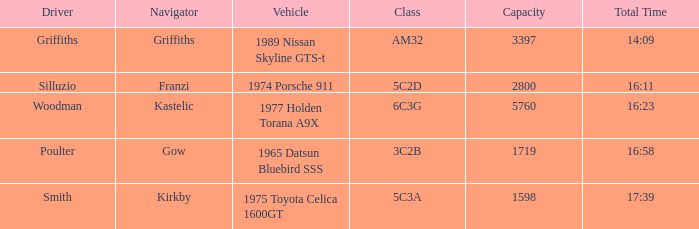Which mode of transportation belongs to the class 6c3g? 1977 Holden Torana A9X. 